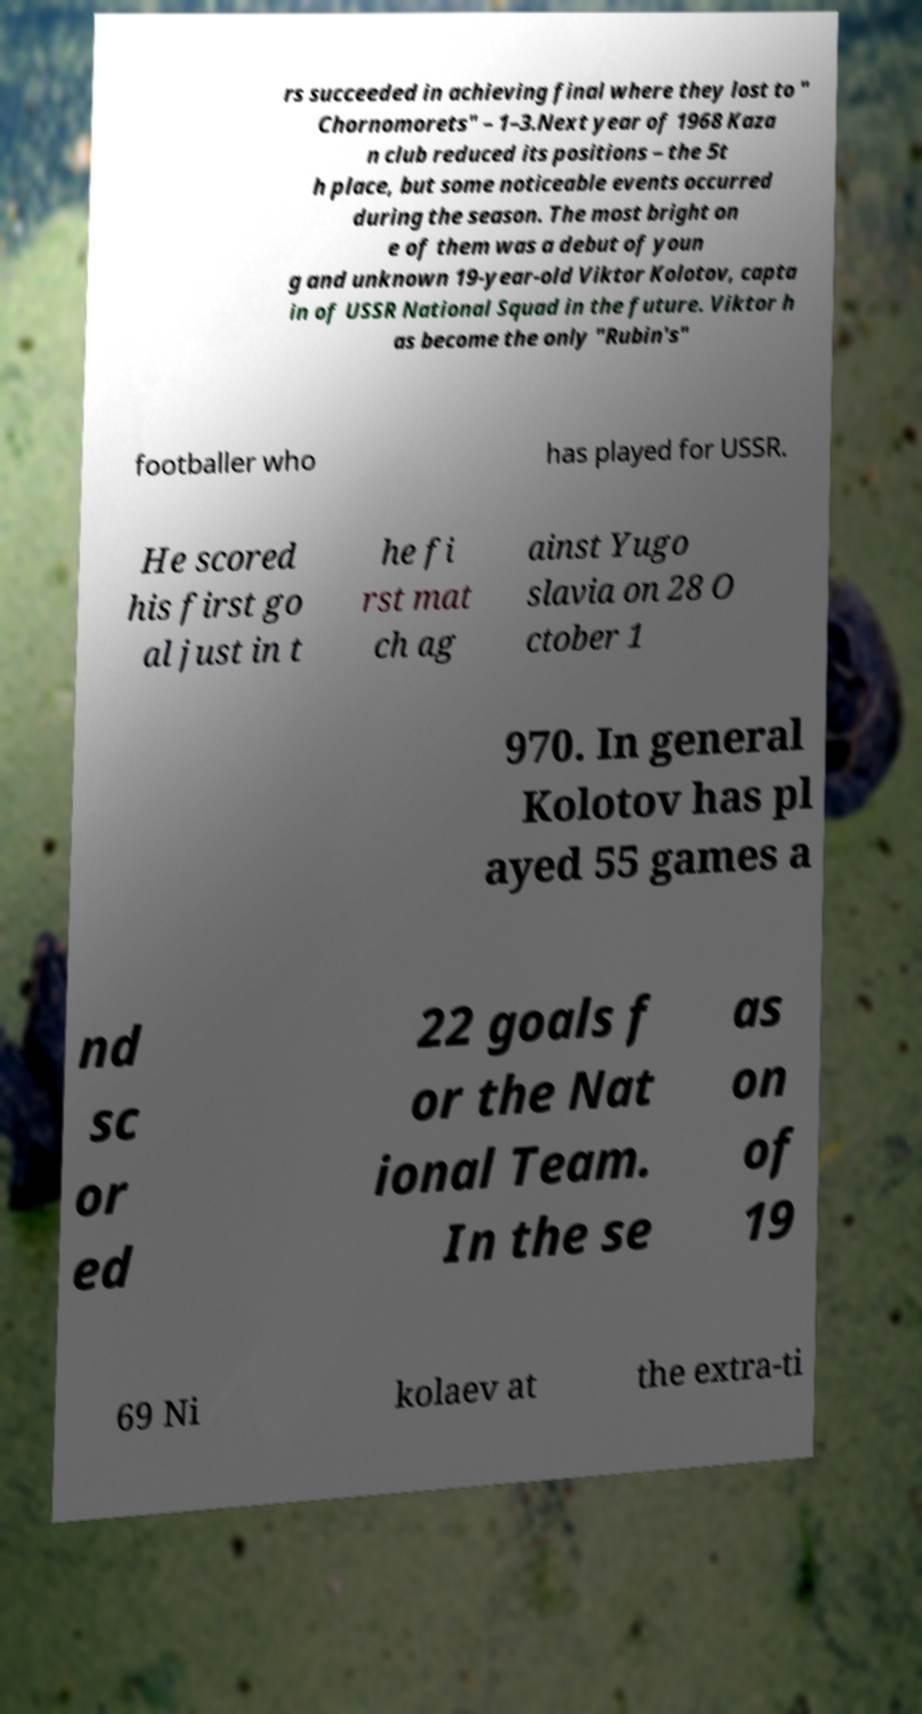For documentation purposes, I need the text within this image transcribed. Could you provide that? rs succeeded in achieving final where they lost to " Chornomorets" – 1–3.Next year of 1968 Kaza n club reduced its positions – the 5t h place, but some noticeable events occurred during the season. The most bright on e of them was a debut of youn g and unknown 19-year-old Viktor Kolotov, capta in of USSR National Squad in the future. Viktor h as become the only "Rubin's" footballer who has played for USSR. He scored his first go al just in t he fi rst mat ch ag ainst Yugo slavia on 28 O ctober 1 970. In general Kolotov has pl ayed 55 games a nd sc or ed 22 goals f or the Nat ional Team. In the se as on of 19 69 Ni kolaev at the extra-ti 